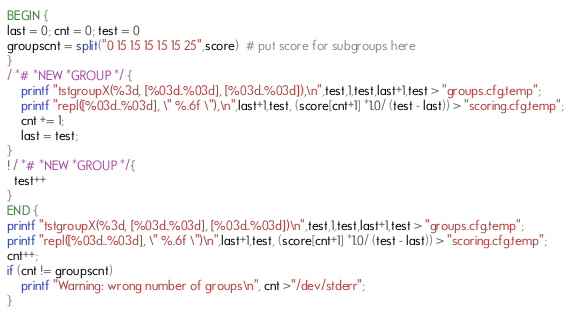Convert code to text. <code><loc_0><loc_0><loc_500><loc_500><_Awk_>BEGIN {
last = 0; cnt = 0; test = 0
groupscnt = split("0 15 15 15 15 15 25",score)  # put score for subgroups here
}
/ *# *NEW *GROUP */ {
    printf "tstgroupX(%3d, [%03d..%03d], [%03d..%03d]),\n",test,1,test,last+1,test > "groups.cfg.temp";
    printf "repl([%03d..%03d], \" %.6f \"),\n",last+1,test, (score[cnt+1] *1.0/ (test - last)) > "scoring.cfg.temp";
    cnt += 1;
    last = test;
}
! / *# *NEW *GROUP */{
  test++
}
END {
printf "tstgroupX(%3d, [%03d..%03d], [%03d..%03d])\n",test,1,test,last+1,test > "groups.cfg.temp";
printf "repl([%03d..%03d], \" %.6f \")\n",last+1,test, (score[cnt+1] *1.0/ (test - last)) > "scoring.cfg.temp";
cnt++;
if (cnt != groupscnt)
    printf "Warning: wrong number of groups\n", cnt >"/dev/stderr";
}
</code> 